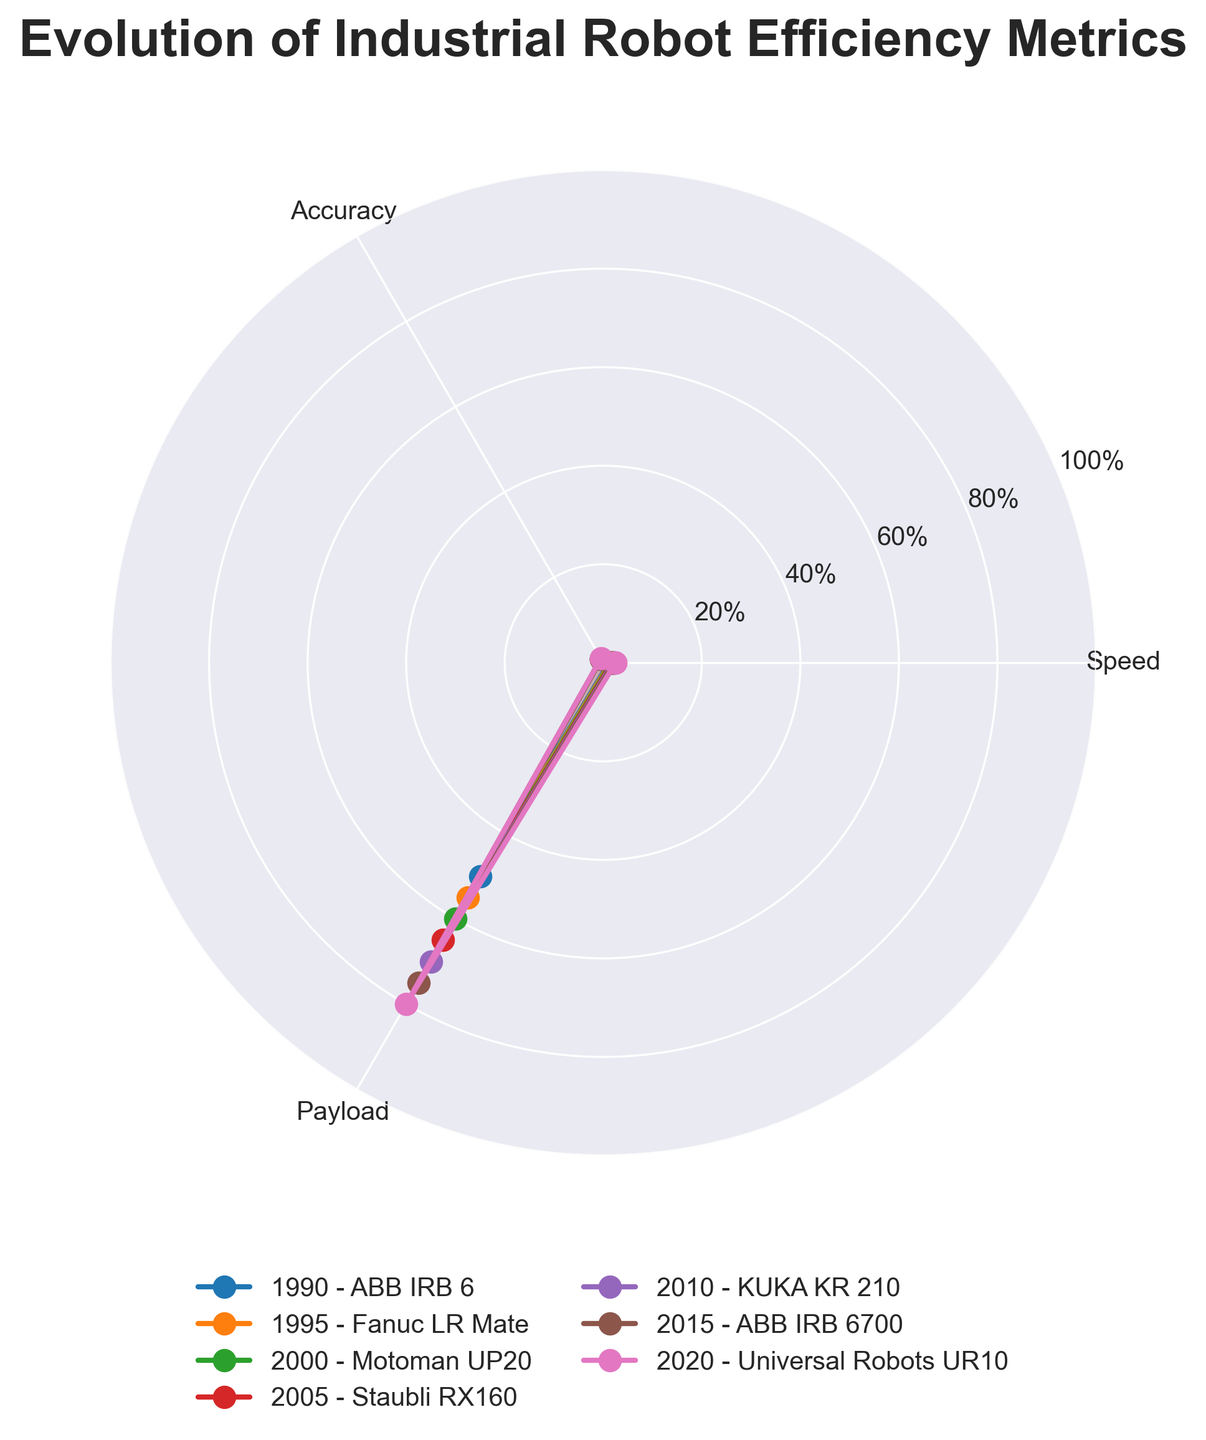What is the title of the chart? The title is usually found at the top of the chart. In this case, it reads "Evolution of Industrial Robot Efficiency Metrics."
Answer: Evolution of Industrial Robot Efficiency Metrics How many efficiency metrics are shown on the chart? By looking at the labels on the axes of the polar chart, we can see that there are three metrics: Speed, Accuracy, and Payload.
Answer: 3 Which year and robot model have the highest payload? We need to find the data point where the Payload value is the highest. By observing the chart, we see that the highest Payload is 80, corresponding to the year 2020 and the Universal Robots UR10 model.
Answer: 2020, Universal Robots UR10 How has the Speed metric evolved from 1990 to 2020? By following the marker points for the Speed metric from 1990 to 2020, we observe that Speed has increased consistently from 1.2 to 2.5 over this period.
Answer: It has increased from 1.2 to 2.5 Between 2000 and 2010, which metric showed the greatest improvement? We compare the changes in values for Speed, Accuracy, and Payload between the years 2000 and 2010. Speed increased from 1.6 to 2.0 (0.4), Accuracy from 0.90 to 0.93 (0.03), and Payload from 60 to 70 (10). The greatest improvement was in Payload.
Answer: Payload Which robot model has the least accuracy, and what is its value? We look for the data point where the Accuracy value is the lowest. From the chart, the least Accuracy is 0.85 for the ABB IRB 6 model in 1990.
Answer: ABB IRB 6, 0.85 What is the average Speed value across all years? The Speed values are 1.2, 1.4, 1.6, 1.8, 2.0, 2.2, and 2.5. To find the average, we sum these values and divide by the number of data points: (1.2 + 1.4 + 1.6 + 1.8 + 2.0 + 2.2 + 2.5) / 7 = 12.7 / 7 = 1.814
Answer: 1.814 Which year shows the most balanced metrics (closest values for Speed, Accuracy, and Payload)? We need to check the values for Speed, Accuracy, and Payload for each year and find which year has the smallest difference between these metrics. In 2015 (Speed = 2.2, Accuracy = 0.95, Payload = 75), the values seem relatively close compared to other years.
Answer: 2015 How many data points (robot models and years) are presented in the figure? We can count the number of distinct lines or markers on the chart, each representing a different year and robot model. There are seven data points in total.
Answer: 7 Which metric has shown the least variability over the years? We observe the range of values for each metric. Speed varies from 1.2 to 2.5, Accuracy from 0.85 to 0.97, and Payload from 50 to 80. The least variability is shown by Accuracy because the range is smallest (0.12).
Answer: Accuracy 